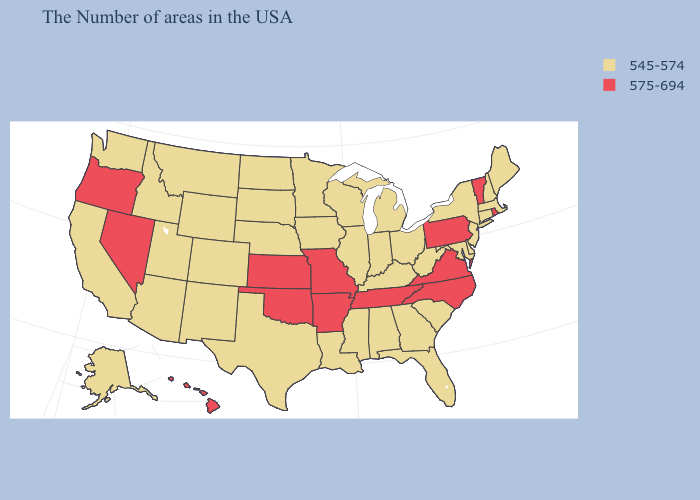Name the states that have a value in the range 545-574?
Concise answer only. Maine, Massachusetts, New Hampshire, Connecticut, New York, New Jersey, Delaware, Maryland, South Carolina, West Virginia, Ohio, Florida, Georgia, Michigan, Kentucky, Indiana, Alabama, Wisconsin, Illinois, Mississippi, Louisiana, Minnesota, Iowa, Nebraska, Texas, South Dakota, North Dakota, Wyoming, Colorado, New Mexico, Utah, Montana, Arizona, Idaho, California, Washington, Alaska. What is the value of California?
Quick response, please. 545-574. Does Missouri have the highest value in the USA?
Give a very brief answer. Yes. Name the states that have a value in the range 545-574?
Concise answer only. Maine, Massachusetts, New Hampshire, Connecticut, New York, New Jersey, Delaware, Maryland, South Carolina, West Virginia, Ohio, Florida, Georgia, Michigan, Kentucky, Indiana, Alabama, Wisconsin, Illinois, Mississippi, Louisiana, Minnesota, Iowa, Nebraska, Texas, South Dakota, North Dakota, Wyoming, Colorado, New Mexico, Utah, Montana, Arizona, Idaho, California, Washington, Alaska. Which states have the highest value in the USA?
Be succinct. Rhode Island, Vermont, Pennsylvania, Virginia, North Carolina, Tennessee, Missouri, Arkansas, Kansas, Oklahoma, Nevada, Oregon, Hawaii. Name the states that have a value in the range 575-694?
Quick response, please. Rhode Island, Vermont, Pennsylvania, Virginia, North Carolina, Tennessee, Missouri, Arkansas, Kansas, Oklahoma, Nevada, Oregon, Hawaii. Name the states that have a value in the range 545-574?
Answer briefly. Maine, Massachusetts, New Hampshire, Connecticut, New York, New Jersey, Delaware, Maryland, South Carolina, West Virginia, Ohio, Florida, Georgia, Michigan, Kentucky, Indiana, Alabama, Wisconsin, Illinois, Mississippi, Louisiana, Minnesota, Iowa, Nebraska, Texas, South Dakota, North Dakota, Wyoming, Colorado, New Mexico, Utah, Montana, Arizona, Idaho, California, Washington, Alaska. What is the highest value in the MidWest ?
Concise answer only. 575-694. Does the first symbol in the legend represent the smallest category?
Quick response, please. Yes. What is the value of Florida?
Keep it brief. 545-574. What is the value of Minnesota?
Write a very short answer. 545-574. Does Rhode Island have a higher value than California?
Answer briefly. Yes. Which states hav the highest value in the Northeast?
Give a very brief answer. Rhode Island, Vermont, Pennsylvania. What is the value of Hawaii?
Give a very brief answer. 575-694. Does California have the lowest value in the USA?
Keep it brief. Yes. 